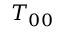Convert formula to latex. <formula><loc_0><loc_0><loc_500><loc_500>T _ { 0 0 }</formula> 